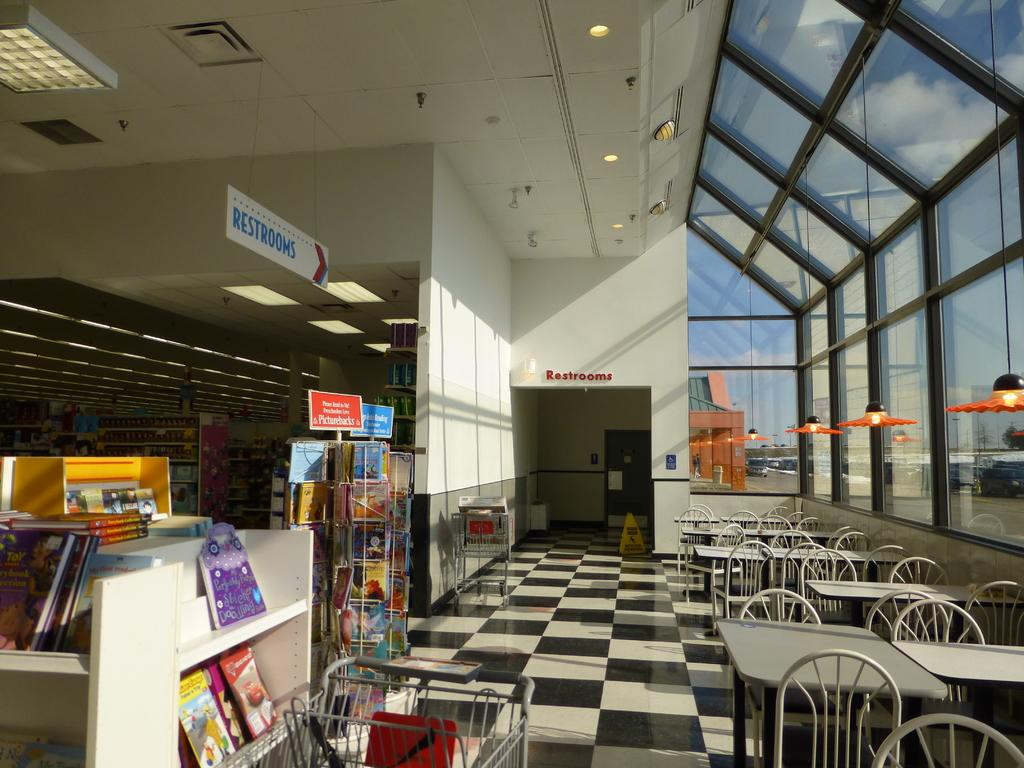<image>
Write a terse but informative summary of the picture. a sign above the books that has restrooms on it 